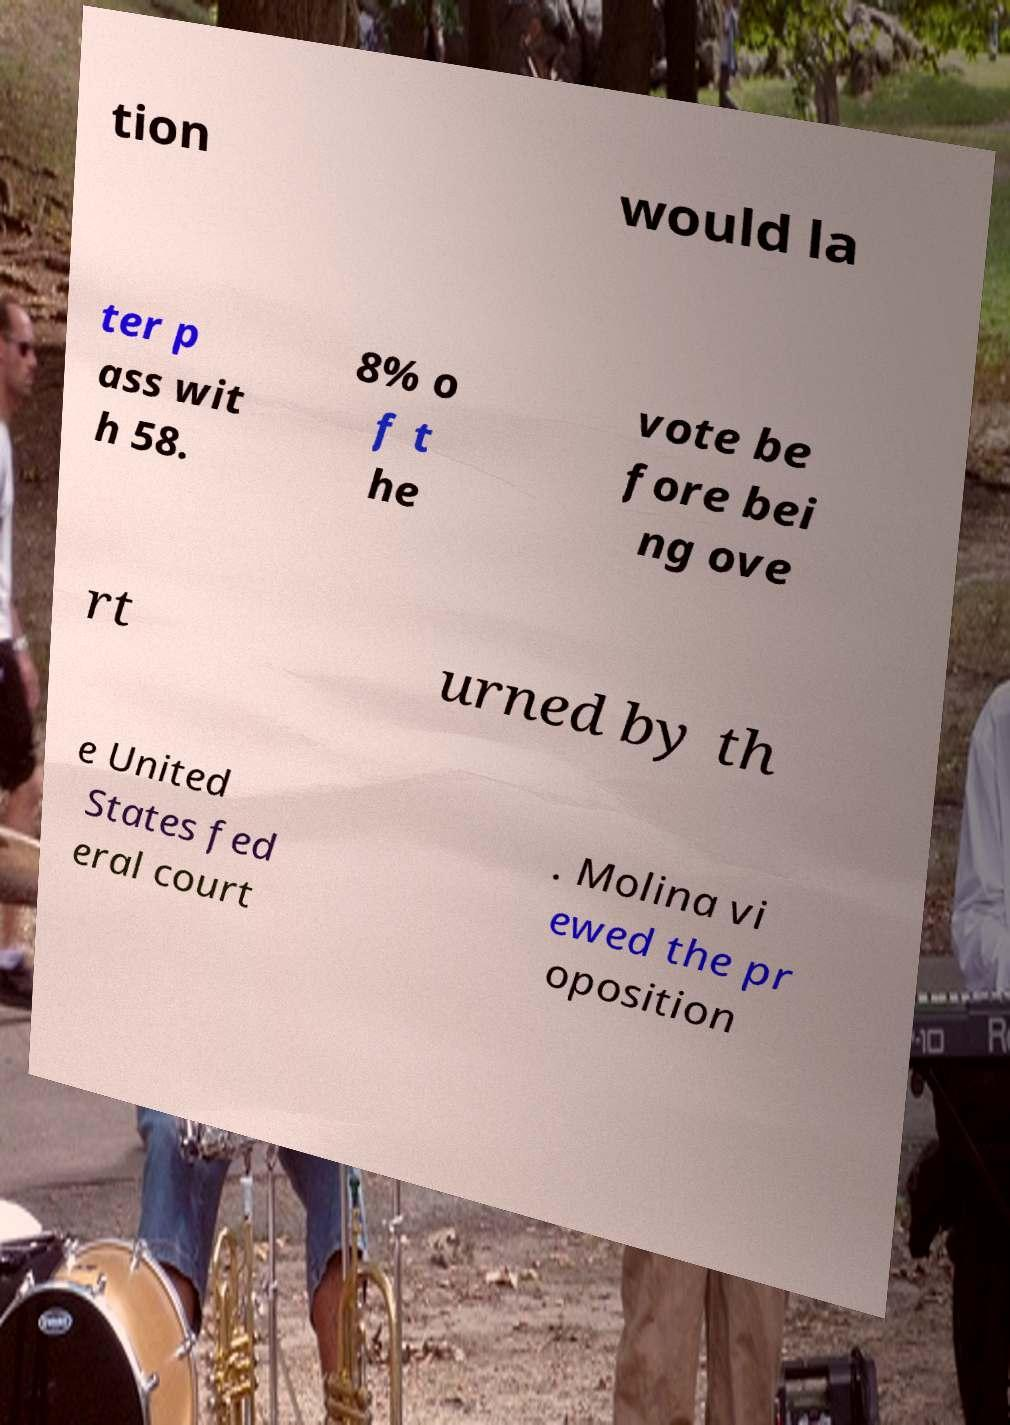Could you extract and type out the text from this image? tion would la ter p ass wit h 58. 8% o f t he vote be fore bei ng ove rt urned by th e United States fed eral court . Molina vi ewed the pr oposition 